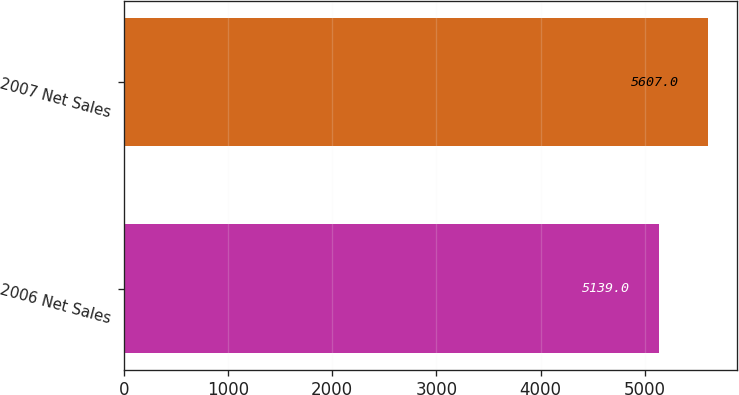<chart> <loc_0><loc_0><loc_500><loc_500><bar_chart><fcel>2006 Net Sales<fcel>2007 Net Sales<nl><fcel>5139<fcel>5607<nl></chart> 